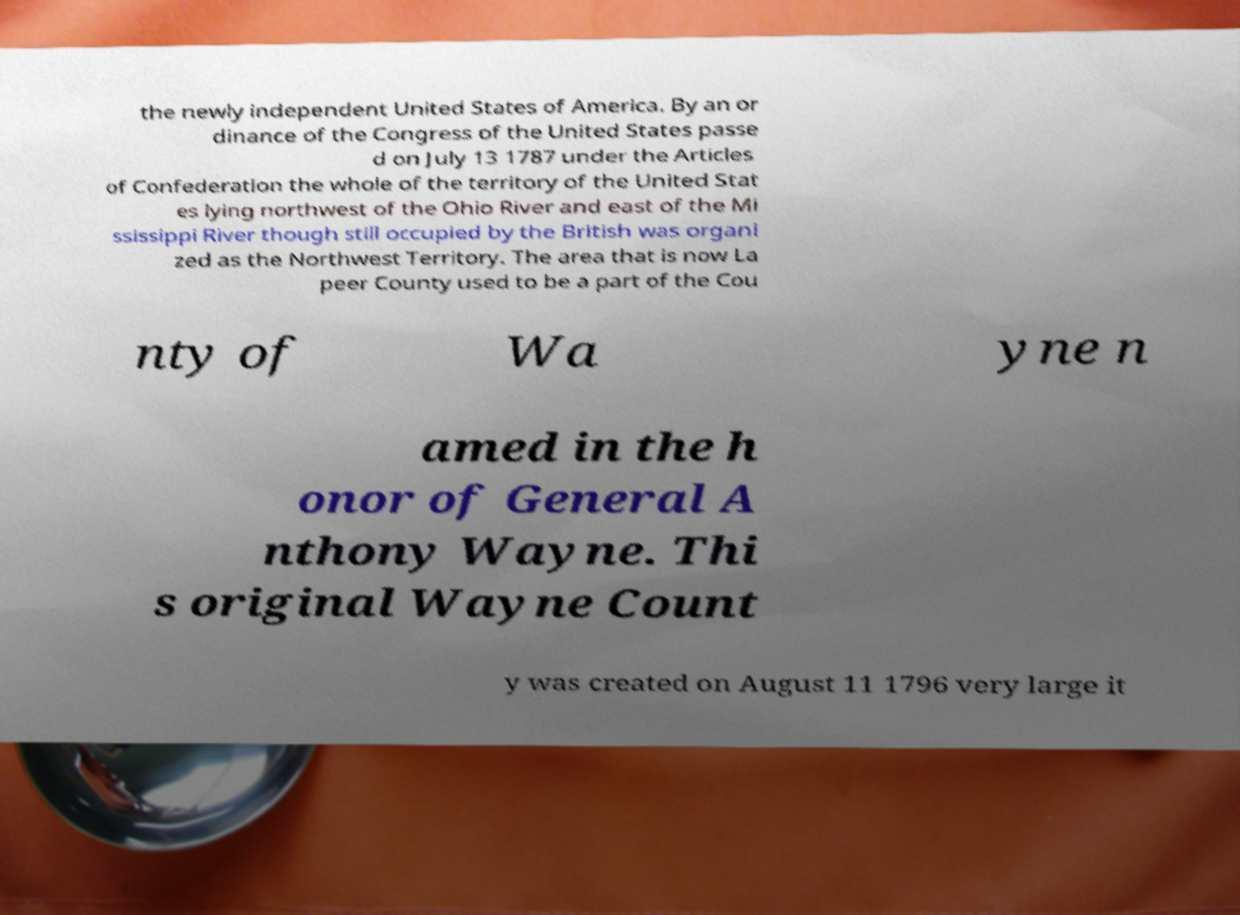Can you accurately transcribe the text from the provided image for me? the newly independent United States of America. By an or dinance of the Congress of the United States passe d on July 13 1787 under the Articles of Confederation the whole of the territory of the United Stat es lying northwest of the Ohio River and east of the Mi ssissippi River though still occupied by the British was organi zed as the Northwest Territory. The area that is now La peer County used to be a part of the Cou nty of Wa yne n amed in the h onor of General A nthony Wayne. Thi s original Wayne Count y was created on August 11 1796 very large it 